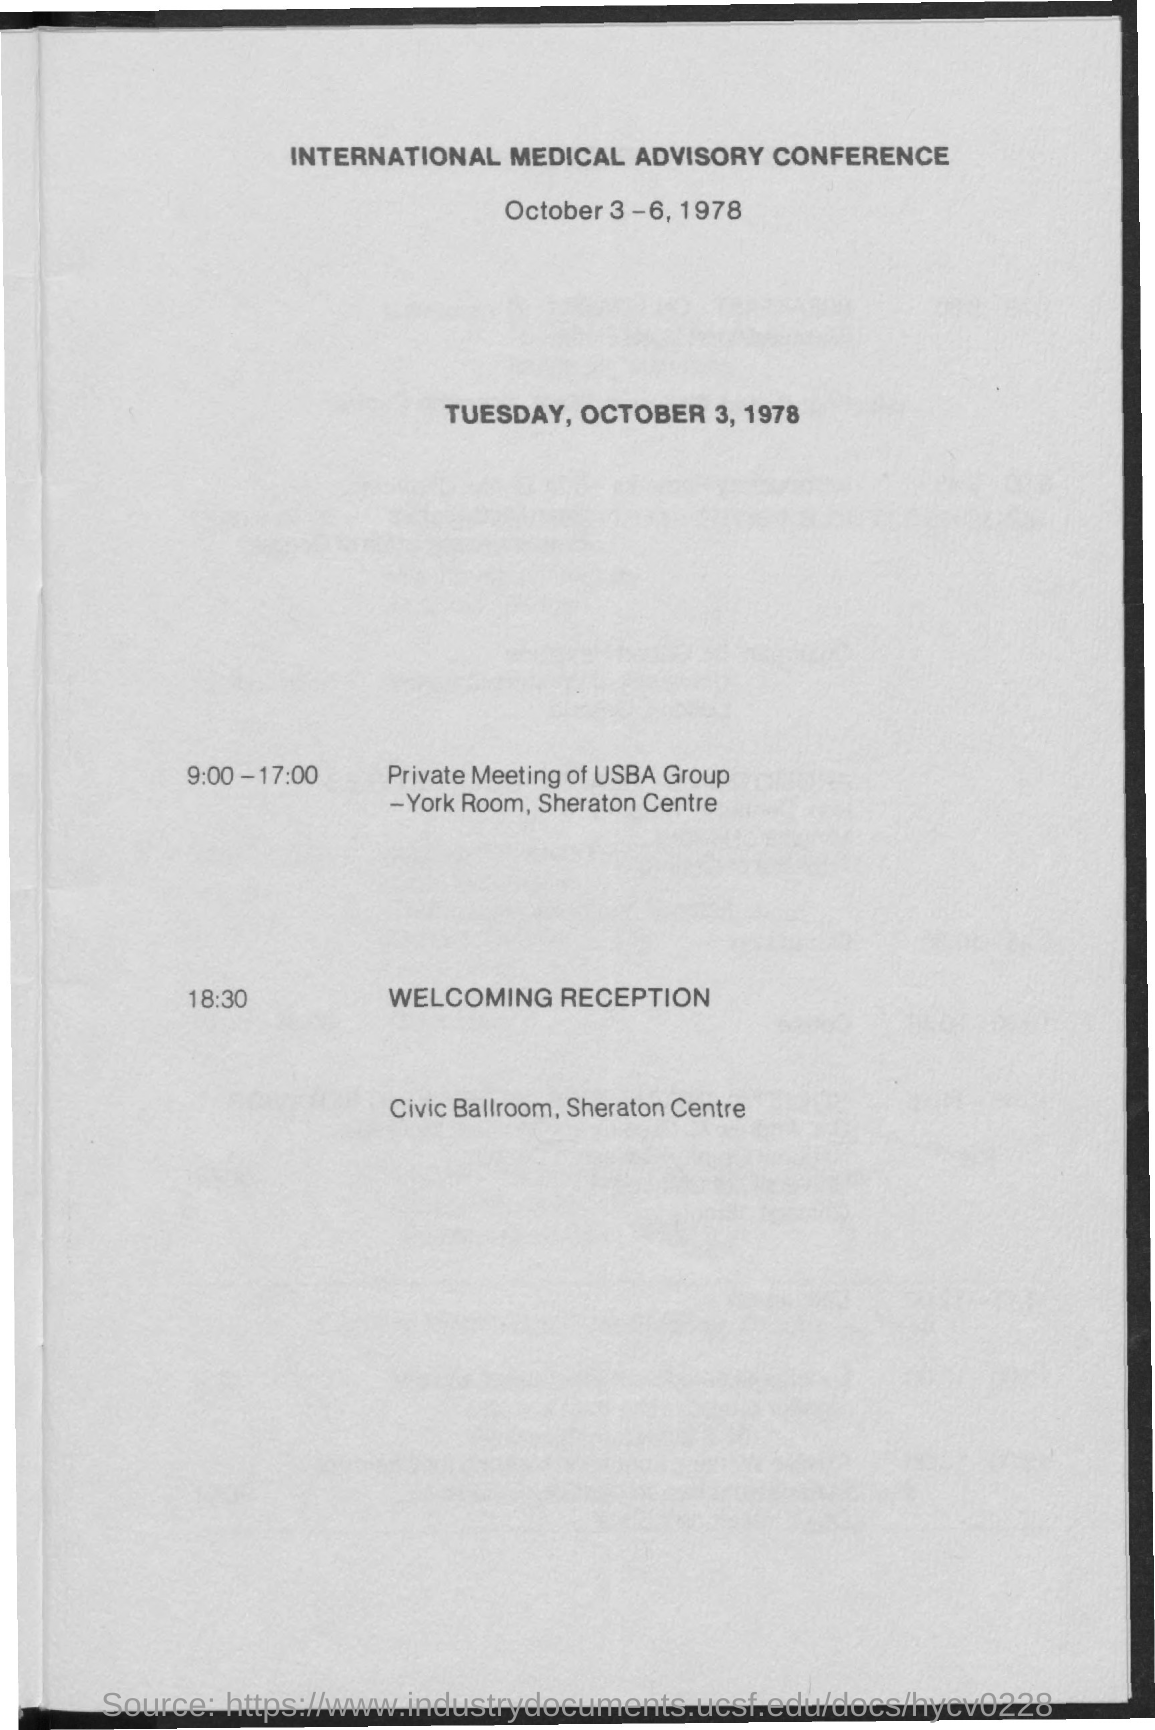What is the conference about?
Offer a very short reply. INTERNATIONAL MEDICAL ADVISORY CONFERENCE. When is the conference going to be held?
Your answer should be very brief. October 3-6, 1978. Where is the welcoming reception?
Keep it short and to the point. CIVIC BALLROOM, SHERATON CENTRE. What is the event from 9:00-17:00?
Make the answer very short. PRIVATE MEETING OF USBA GROUP. 